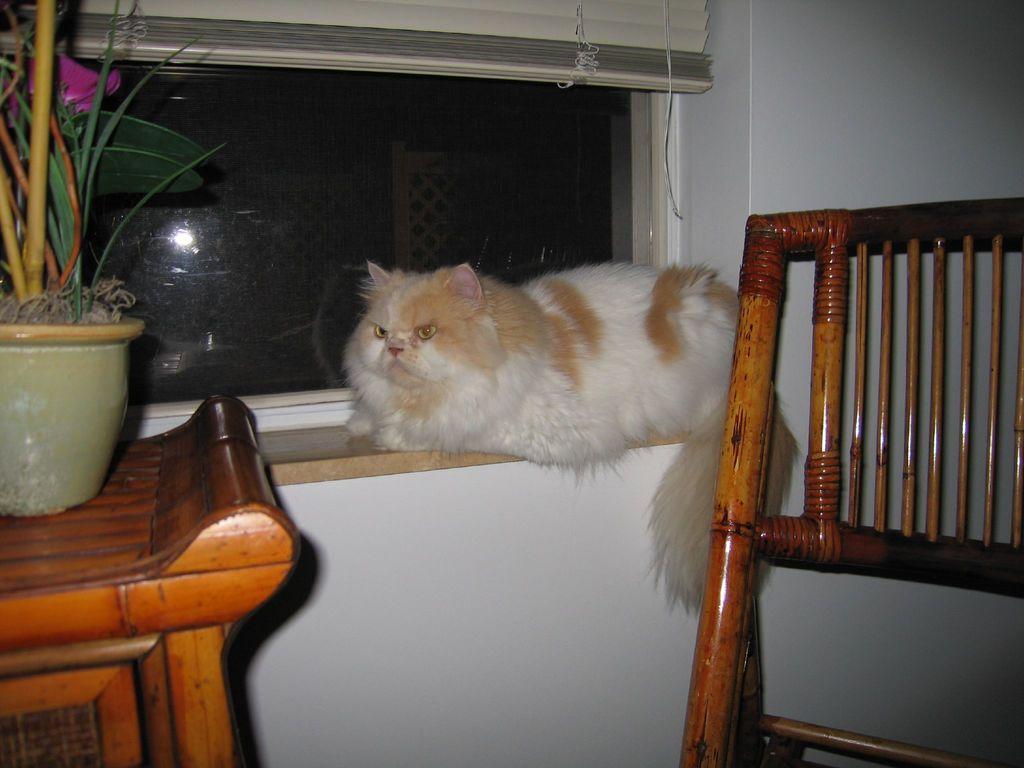Can you describe this image briefly? There is a cat, sitting on the window of a room. There is a chair and a table on which a flower pot is placed. We can observe a window and a wall in the background. 